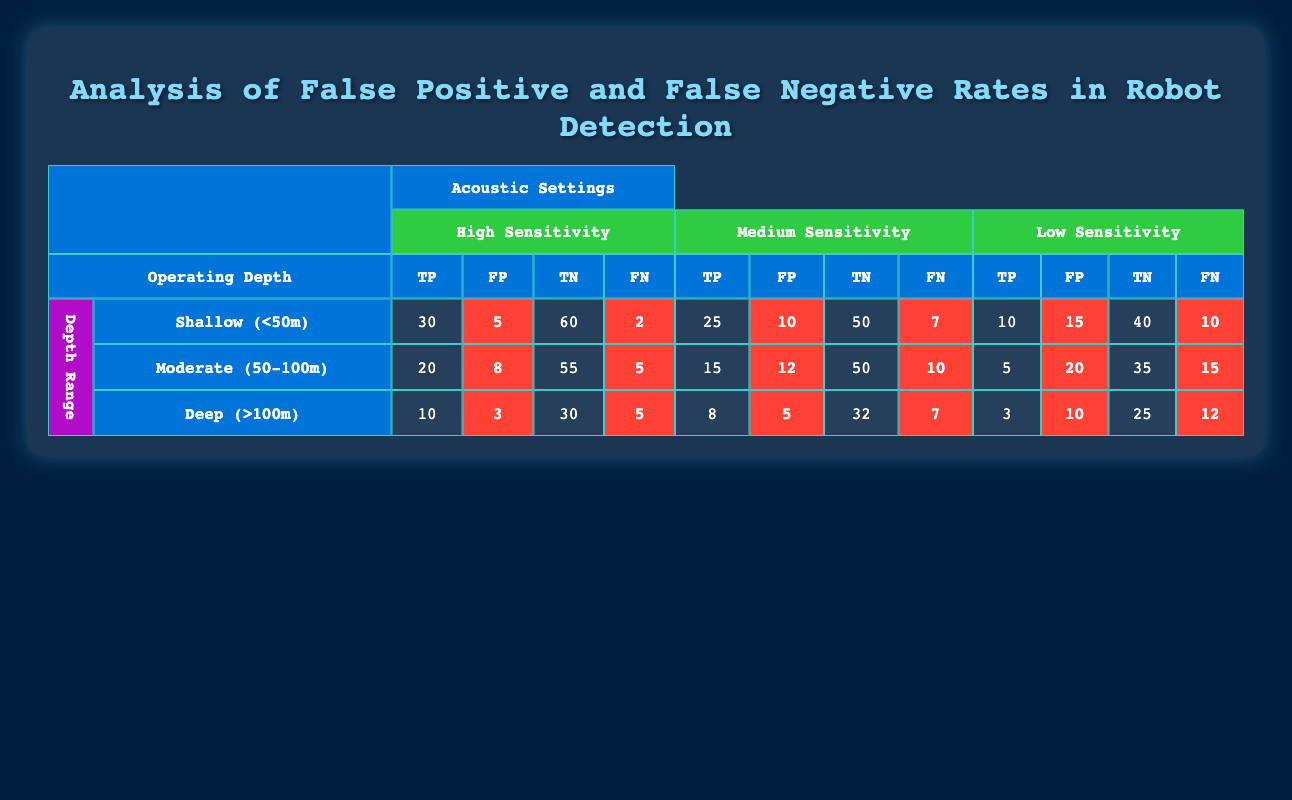What is the False Positive rate for High Sensitivity in Shallow depth? The False Positive rate is calculated by dividing the number of False Positives by the sum of True Positives and False Positives. For Shallow depth and High Sensitivity, the False Positive count is 5, and True Positive count is 30. So, the rate is 5/(30 + 5) = 5/35 = 0.142857, or approximately 14.29%.
Answer: 14.29% Which sensitivity setting has the highest True Negatives in Deep depth? For Deep depth, the True Negatives values are: High Sensitivity = 30, Medium Sensitivity = 32, and Low Sensitivity = 25. Medium Sensitivity has the highest value at 32 True Negatives.
Answer: Medium Sensitivity What is the total number of True Positives across all depths for Low Sensitivity? The True Positives for Low Sensitivity are: Shallow = 10, Moderate = 5, and Deep = 3. Adding these together gives 10 + 5 + 3 = 18.
Answer: 18 Is the False Negative rate for Moderate depth and Medium Sensitivity greater than the False Negative rate for Shallow depth and High Sensitivity? For Moderate depth and Medium Sensitivity, the False Negatives are 10; for Shallow depth and High Sensitivity, it's 2. Since 10 is greater than 2, the statement is true.
Answer: Yes Which depth and sensitivity combination has the lowest True Positives? By reviewing the True Positives, for Deep depth and Low Sensitivity, the number is 3. It's lower than any other combination: Shallow and Moderate depths have higher counts.
Answer: Deep (>100m) with Low Sensitivity What is the combined total of False Positives for all sensitivity settings at Shallow depth? The False Positives for Shallow depth are: High Sensitivity = 5, Medium Sensitivity = 10, and Low Sensitivity = 15. Adding them gives 5 + 10 + 15 = 30.
Answer: 30 How much greater is the number of False Negatives for Low Sensitivity in Moderate depth than in Shallow depth? For Low Sensitivity, the False Negatives are 15 in Moderate depth and 10 in Shallow depth. To find the difference: 15 - 10 = 5.
Answer: 5 Which sensitivity setting has the least False Positives when operating at Deep depth? Looking at Deep depth: High Sensitivity has 3 False Positives, Medium Sensitivity has 5, and Low Sensitivity has 10. The least is 3 with High Sensitivity.
Answer: High Sensitivity What is the average False Positive rate for all depths at Medium Sensitivity? The False Positives for Medium Sensitivity across depths are: Shallow = 10, Moderate = 12, and Deep = 5. The total False Positives are 10 + 12 + 5 = 27. There are three samples, so the average rate is 27/3 = 9.
Answer: 9 